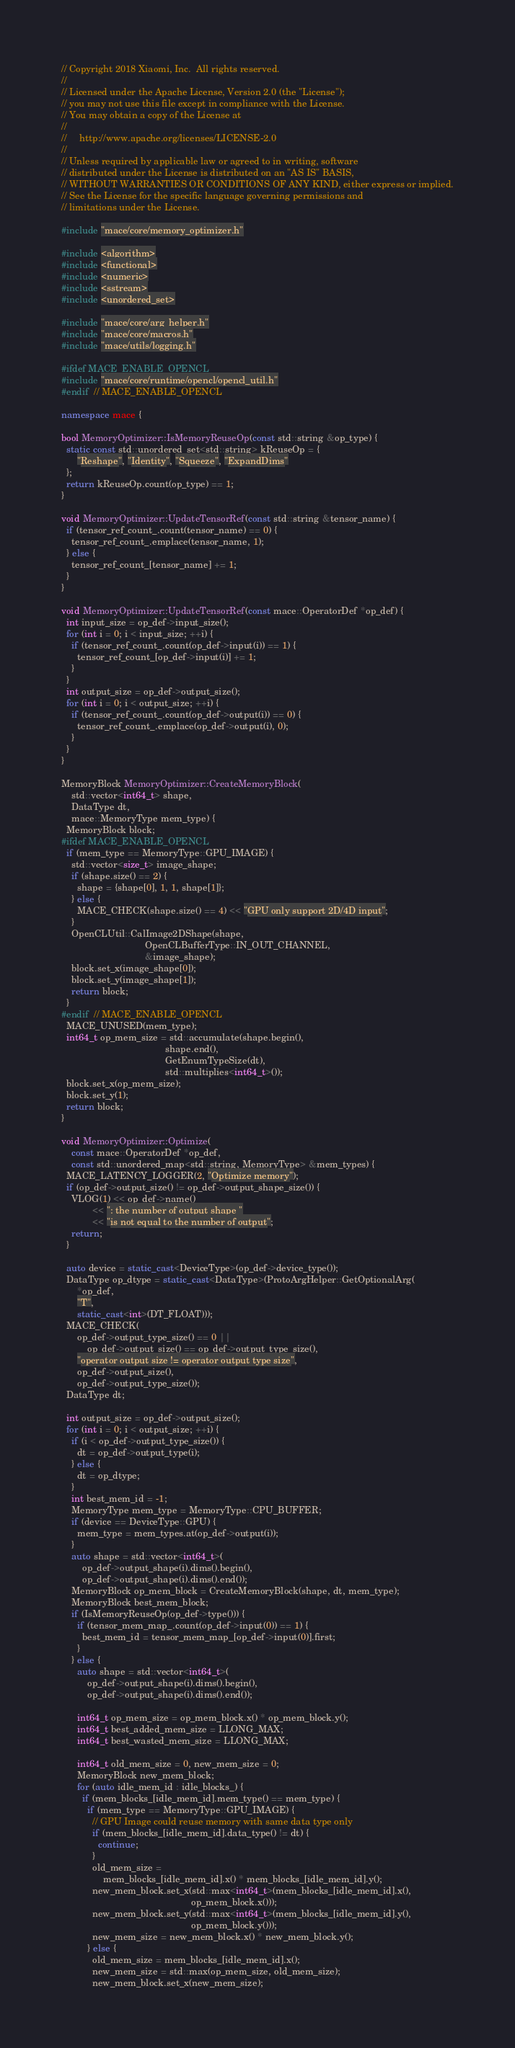Convert code to text. <code><loc_0><loc_0><loc_500><loc_500><_C++_>// Copyright 2018 Xiaomi, Inc.  All rights reserved.
//
// Licensed under the Apache License, Version 2.0 (the "License");
// you may not use this file except in compliance with the License.
// You may obtain a copy of the License at
//
//     http://www.apache.org/licenses/LICENSE-2.0
//
// Unless required by applicable law or agreed to in writing, software
// distributed under the License is distributed on an "AS IS" BASIS,
// WITHOUT WARRANTIES OR CONDITIONS OF ANY KIND, either express or implied.
// See the License for the specific language governing permissions and
// limitations under the License.

#include "mace/core/memory_optimizer.h"

#include <algorithm>
#include <functional>
#include <numeric>
#include <sstream>
#include <unordered_set>

#include "mace/core/arg_helper.h"
#include "mace/core/macros.h"
#include "mace/utils/logging.h"

#ifdef MACE_ENABLE_OPENCL
#include "mace/core/runtime/opencl/opencl_util.h"
#endif  // MACE_ENABLE_OPENCL

namespace mace {

bool MemoryOptimizer::IsMemoryReuseOp(const std::string &op_type) {
  static const std::unordered_set<std::string> kReuseOp = {
      "Reshape", "Identity", "Squeeze", "ExpandDims"
  };
  return kReuseOp.count(op_type) == 1;
}

void MemoryOptimizer::UpdateTensorRef(const std::string &tensor_name) {
  if (tensor_ref_count_.count(tensor_name) == 0) {
    tensor_ref_count_.emplace(tensor_name, 1);
  } else {
    tensor_ref_count_[tensor_name] += 1;
  }
}

void MemoryOptimizer::UpdateTensorRef(const mace::OperatorDef *op_def) {
  int input_size = op_def->input_size();
  for (int i = 0; i < input_size; ++i) {
    if (tensor_ref_count_.count(op_def->input(i)) == 1) {
      tensor_ref_count_[op_def->input(i)] += 1;
    }
  }
  int output_size = op_def->output_size();
  for (int i = 0; i < output_size; ++i) {
    if (tensor_ref_count_.count(op_def->output(i)) == 0) {
      tensor_ref_count_.emplace(op_def->output(i), 0);
    }
  }
}

MemoryBlock MemoryOptimizer::CreateMemoryBlock(
    std::vector<int64_t> shape,
    DataType dt,
    mace::MemoryType mem_type) {
  MemoryBlock block;
#ifdef MACE_ENABLE_OPENCL
  if (mem_type == MemoryType::GPU_IMAGE) {
    std::vector<size_t> image_shape;
    if (shape.size() == 2) {
      shape = {shape[0], 1, 1, shape[1]};
    } else {
      MACE_CHECK(shape.size() == 4) << "GPU only support 2D/4D input";
    }
    OpenCLUtil::CalImage2DShape(shape,
                                OpenCLBufferType::IN_OUT_CHANNEL,
                                &image_shape);
    block.set_x(image_shape[0]);
    block.set_y(image_shape[1]);
    return block;
  }
#endif  // MACE_ENABLE_OPENCL
  MACE_UNUSED(mem_type);
  int64_t op_mem_size = std::accumulate(shape.begin(),
                                        shape.end(),
                                        GetEnumTypeSize(dt),
                                        std::multiplies<int64_t>());
  block.set_x(op_mem_size);
  block.set_y(1);
  return block;
}

void MemoryOptimizer::Optimize(
    const mace::OperatorDef *op_def,
    const std::unordered_map<std::string, MemoryType> &mem_types) {
  MACE_LATENCY_LOGGER(2, "Optimize memory");
  if (op_def->output_size() != op_def->output_shape_size()) {
    VLOG(1) << op_def->name()
            << ": the number of output shape "
            << "is not equal to the number of output";
    return;
  }

  auto device = static_cast<DeviceType>(op_def->device_type());
  DataType op_dtype = static_cast<DataType>(ProtoArgHelper::GetOptionalArg(
      *op_def,
      "T",
      static_cast<int>(DT_FLOAT)));
  MACE_CHECK(
      op_def->output_type_size() == 0 ||
          op_def->output_size() == op_def->output_type_size(),
      "operator output size != operator output type size",
      op_def->output_size(),
      op_def->output_type_size());
  DataType dt;

  int output_size = op_def->output_size();
  for (int i = 0; i < output_size; ++i) {
    if (i < op_def->output_type_size()) {
      dt = op_def->output_type(i);
    } else {
      dt = op_dtype;
    }
    int best_mem_id = -1;
    MemoryType mem_type = MemoryType::CPU_BUFFER;
    if (device == DeviceType::GPU) {
      mem_type = mem_types.at(op_def->output(i));
    }
    auto shape = std::vector<int64_t>(
        op_def->output_shape(i).dims().begin(),
        op_def->output_shape(i).dims().end());
    MemoryBlock op_mem_block = CreateMemoryBlock(shape, dt, mem_type);
    MemoryBlock best_mem_block;
    if (IsMemoryReuseOp(op_def->type())) {
      if (tensor_mem_map_.count(op_def->input(0)) == 1) {
        best_mem_id = tensor_mem_map_[op_def->input(0)].first;
      }
    } else {
      auto shape = std::vector<int64_t>(
          op_def->output_shape(i).dims().begin(),
          op_def->output_shape(i).dims().end());

      int64_t op_mem_size = op_mem_block.x() * op_mem_block.y();
      int64_t best_added_mem_size = LLONG_MAX;
      int64_t best_wasted_mem_size = LLONG_MAX;

      int64_t old_mem_size = 0, new_mem_size = 0;
      MemoryBlock new_mem_block;
      for (auto idle_mem_id : idle_blocks_) {
        if (mem_blocks_[idle_mem_id].mem_type() == mem_type) {
          if (mem_type == MemoryType::GPU_IMAGE) {
            // GPU Image could reuse memory with same data type only
            if (mem_blocks_[idle_mem_id].data_type() != dt) {
              continue;
            }
            old_mem_size =
                mem_blocks_[idle_mem_id].x() * mem_blocks_[idle_mem_id].y();
            new_mem_block.set_x(std::max<int64_t>(mem_blocks_[idle_mem_id].x(),
                                                  op_mem_block.x()));
            new_mem_block.set_y(std::max<int64_t>(mem_blocks_[idle_mem_id].y(),
                                                  op_mem_block.y()));
            new_mem_size = new_mem_block.x() * new_mem_block.y();
          } else {
            old_mem_size = mem_blocks_[idle_mem_id].x();
            new_mem_size = std::max(op_mem_size, old_mem_size);
            new_mem_block.set_x(new_mem_size);</code> 